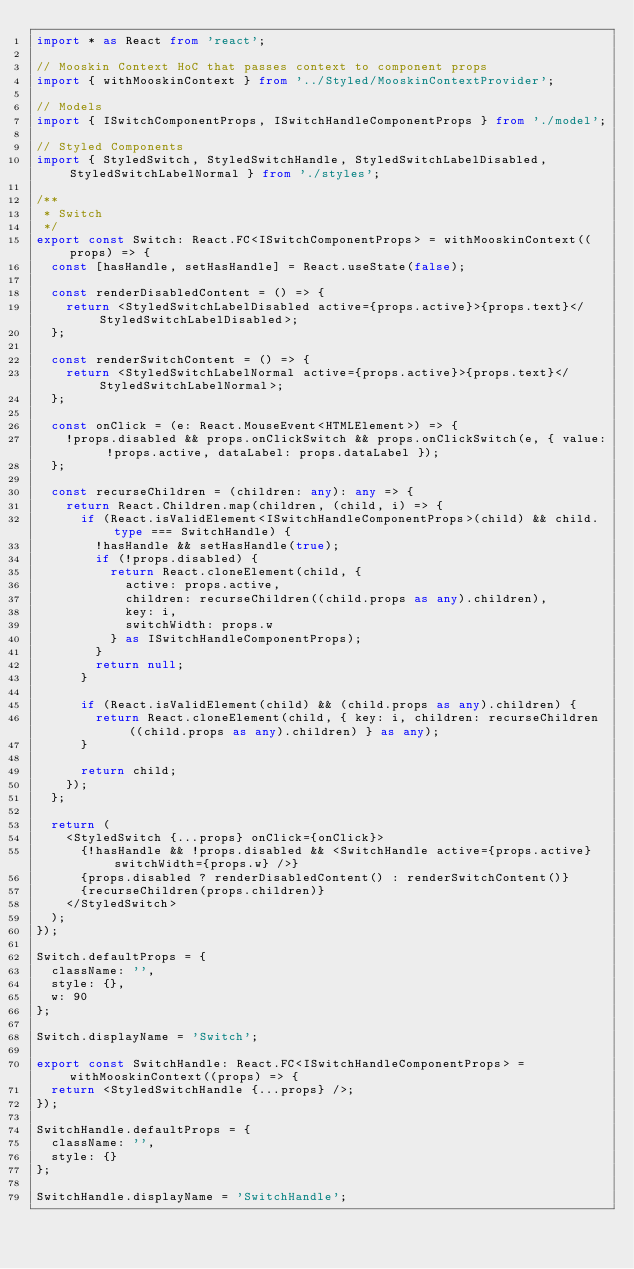Convert code to text. <code><loc_0><loc_0><loc_500><loc_500><_TypeScript_>import * as React from 'react';

// Mooskin Context HoC that passes context to component props
import { withMooskinContext } from '../Styled/MooskinContextProvider';

// Models
import { ISwitchComponentProps, ISwitchHandleComponentProps } from './model';

// Styled Components
import { StyledSwitch, StyledSwitchHandle, StyledSwitchLabelDisabled, StyledSwitchLabelNormal } from './styles';

/**
 * Switch
 */
export const Switch: React.FC<ISwitchComponentProps> = withMooskinContext((props) => {
	const [hasHandle, setHasHandle] = React.useState(false);

	const renderDisabledContent = () => {
		return <StyledSwitchLabelDisabled active={props.active}>{props.text}</StyledSwitchLabelDisabled>;
	};

	const renderSwitchContent = () => {
		return <StyledSwitchLabelNormal active={props.active}>{props.text}</StyledSwitchLabelNormal>;
	};

	const onClick = (e: React.MouseEvent<HTMLElement>) => {
		!props.disabled && props.onClickSwitch && props.onClickSwitch(e, { value: !props.active, dataLabel: props.dataLabel });
	};

	const recurseChildren = (children: any): any => {
		return React.Children.map(children, (child, i) => {
			if (React.isValidElement<ISwitchHandleComponentProps>(child) && child.type === SwitchHandle) {
				!hasHandle && setHasHandle(true);
				if (!props.disabled) {
					return React.cloneElement(child, {
						active: props.active,
						children: recurseChildren((child.props as any).children),
						key: i,
						switchWidth: props.w
					} as ISwitchHandleComponentProps);
				}
				return null;
			}

			if (React.isValidElement(child) && (child.props as any).children) {
				return React.cloneElement(child, { key: i, children: recurseChildren((child.props as any).children) } as any);
			}

			return child;
		});
	};

	return (
		<StyledSwitch {...props} onClick={onClick}>
			{!hasHandle && !props.disabled && <SwitchHandle active={props.active} switchWidth={props.w} />}
			{props.disabled ? renderDisabledContent() : renderSwitchContent()}
			{recurseChildren(props.children)}
		</StyledSwitch>
	);
});

Switch.defaultProps = {
	className: '',
	style: {},
	w: 90
};

Switch.displayName = 'Switch';

export const SwitchHandle: React.FC<ISwitchHandleComponentProps> = withMooskinContext((props) => {
	return <StyledSwitchHandle {...props} />;
});

SwitchHandle.defaultProps = {
	className: '',
	style: {}
};

SwitchHandle.displayName = 'SwitchHandle';
</code> 